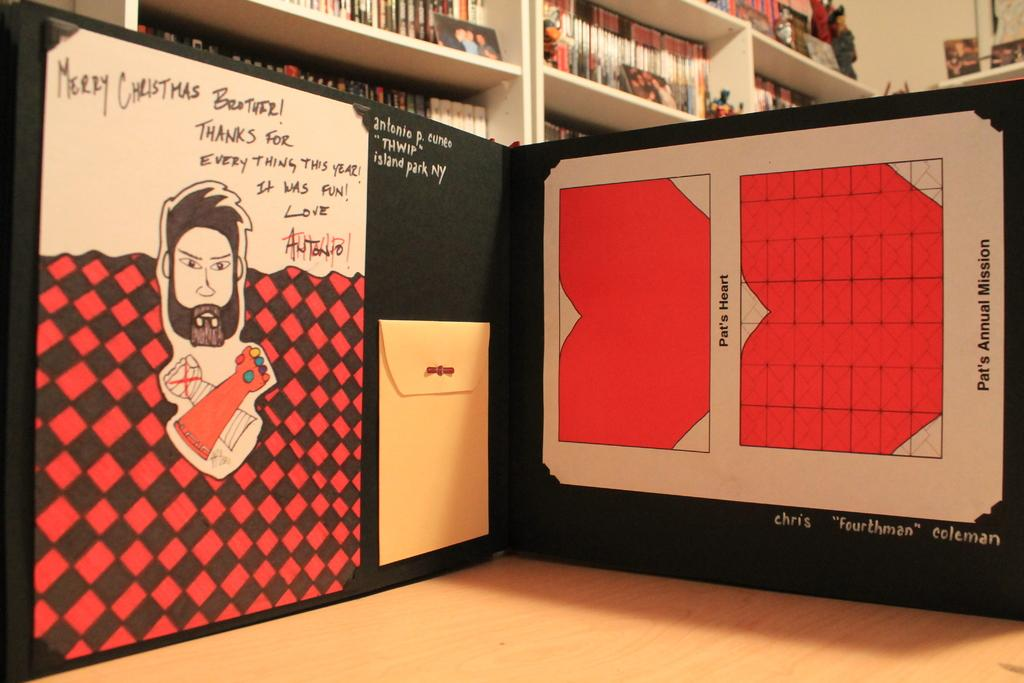<image>
Give a short and clear explanation of the subsequent image. A personal note from Antonio is scribbled on a colorful card. 